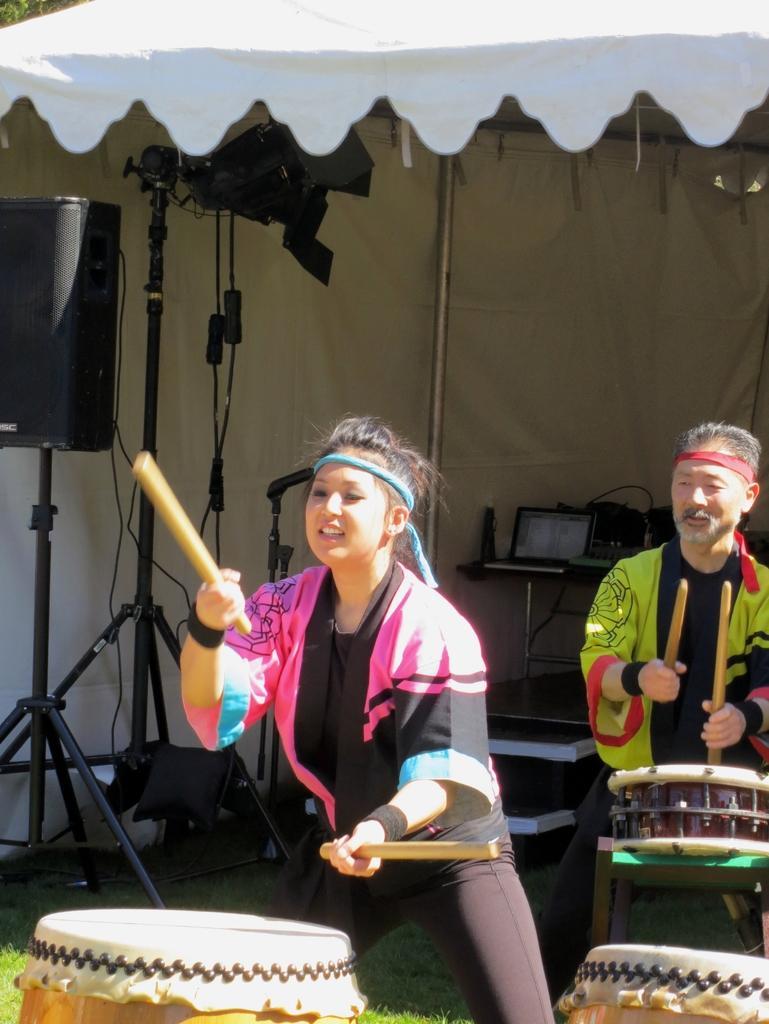In one or two sentences, can you explain what this image depicts? A lady with pink and black dress is beating to the drums. In her both hands there are sticks. To the right side there is a man with green and black dress he is also beating drums. To the left corner there is a speaker and some video cameras. In the background there are some laptops on the table. On the top there is a tent. They both are on the grass. 